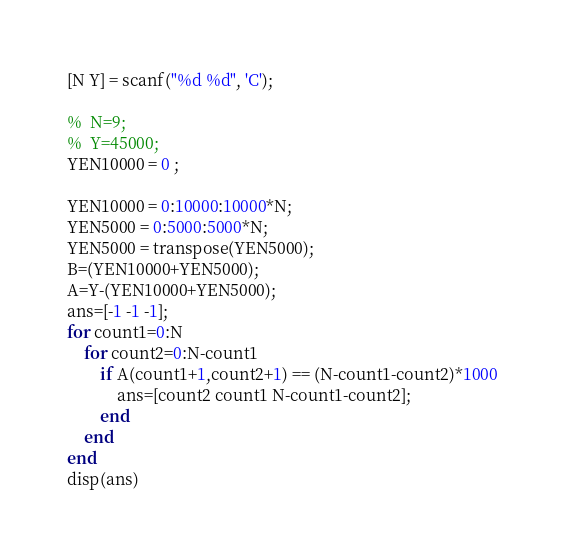<code> <loc_0><loc_0><loc_500><loc_500><_Octave_>[N Y] = scanf("%d %d", 'C');

%  N=9;
%  Y=45000;
YEN10000 = 0 ;

YEN10000 = 0:10000:10000*N;
YEN5000 = 0:5000:5000*N;
YEN5000 = transpose(YEN5000);
B=(YEN10000+YEN5000);
A=Y-(YEN10000+YEN5000);
ans=[-1 -1 -1];
for count1=0:N
    for count2=0:N-count1
        if A(count1+1,count2+1) == (N-count1-count2)*1000
            ans=[count2 count1 N-count1-count2];
        end
    end
end
disp(ans)

</code> 